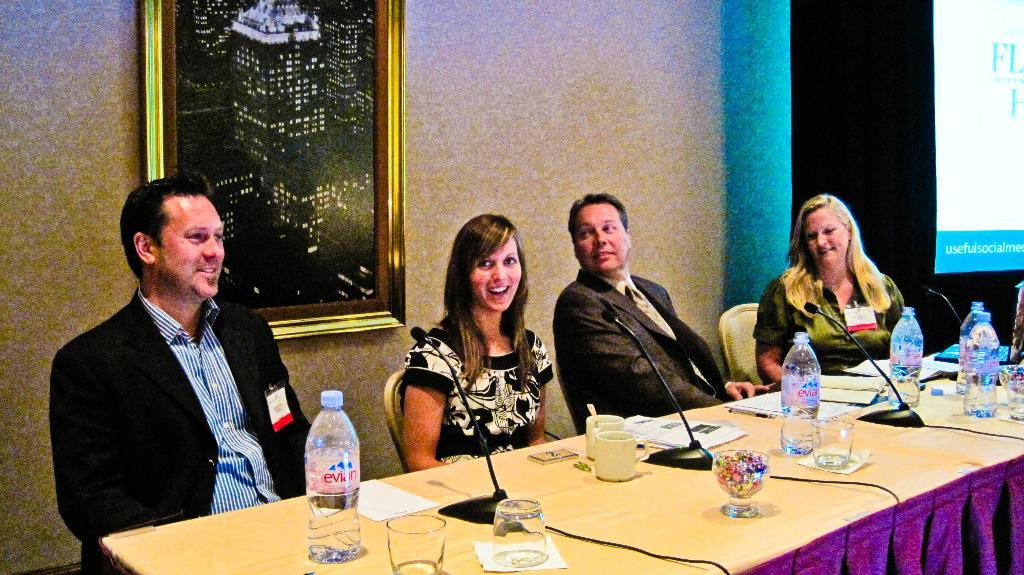What is the general activity of the people in the image? The people in the image are seated and smiling, which suggests they are engaged in a social or friendly gathering. What items can be seen on the table in the image? There are water bottles, glasses, and a microphone on the table in the image. What is present on the wall in the image? There is a frame on the wall in the image. What is the price of the rabbit in the image? There is no rabbit present in the image, so it is not possible to determine its price. 